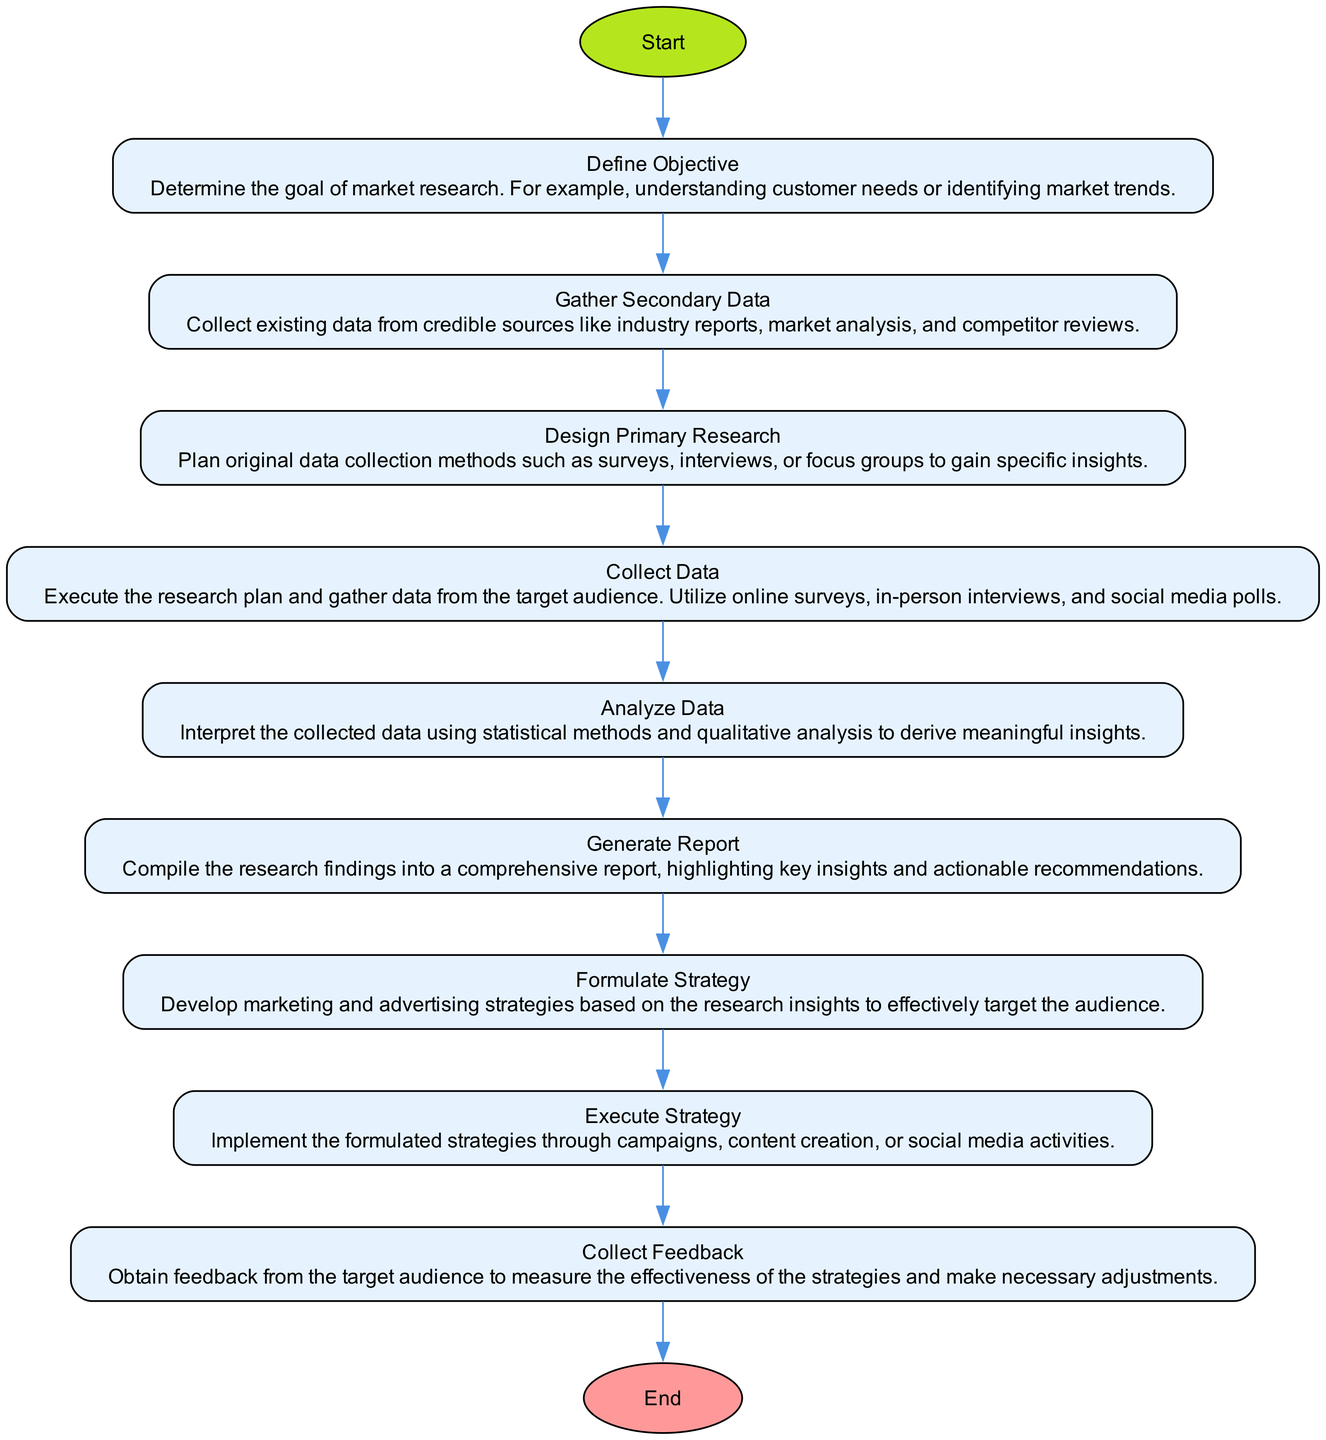What is the first step in the market research process? The diagram starts with the "Define Objective" node, which indicates that determining the goal of market research is the first step.
Answer: Define Objective How many steps are there in total? By counting the nodes listed in the diagram, including the start and end nodes, there are a total of ten steps in the market research process.
Answer: Ten What is the last step in the diagram? The flow chart concludes at the "Collect Feedback" step before reaching the end node, indicating that gathering feedback is the final actionable step in the process.
Answer: Collect Feedback What comes after analyzing data? Following the "Analyze Data" step, the next step is "Generate Report," which means that report creation comes right after data analysis.
Answer: Generate Report Which step involves implementing strategies? The "Execute Strategy" step focuses on putting the formulated strategies into action, indicating the phase where plans are actualized through various activities.
Answer: Execute Strategy How does the step "Design Primary Research" connect to the overall process? "Design Primary Research" is a critical step that follows gathering secondary data and leads into collecting data, establishing a pathway for conducting tailored original research.
Answer: It follows gathering secondary data and leads into collecting data What is the purpose of gathering secondary data? The purpose is to collect existing data from credible sources, which helps inform the research design and provides background before proceeding to primary research.
Answer: To collect existing data from credible sources How does feedback influence the process? Feedback collected at the final step measures the effectiveness of strategies implemented, which can lead to adjustments and improvements, showcasing the iterative nature of market research.
Answer: It measures effectiveness and leads to adjustments 